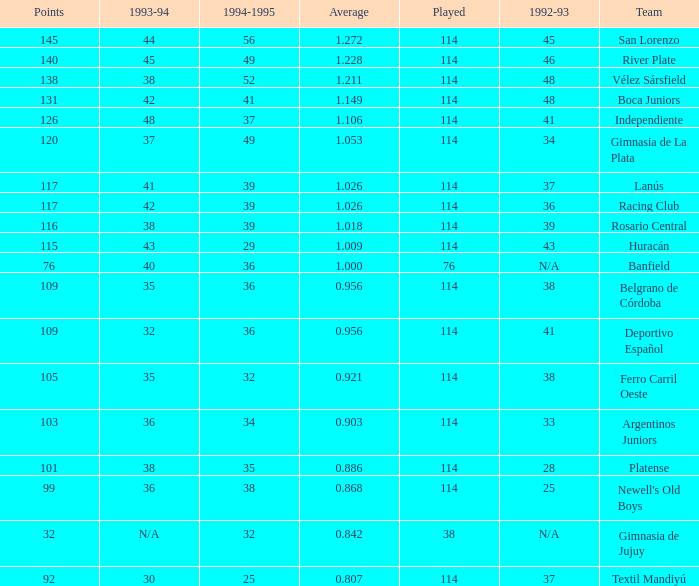Name the most played 114.0. 